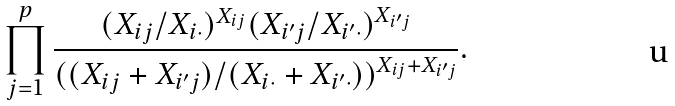Convert formula to latex. <formula><loc_0><loc_0><loc_500><loc_500>\prod _ { j = 1 } ^ { p } \frac { ( X _ { i j } / X _ { i \cdot } ) ^ { X _ { i j } } ( X _ { i ^ { \prime } j } / X _ { i ^ { \prime } \cdot } ) ^ { X _ { i ^ { \prime } j } } } { ( ( X _ { i j } + X _ { i ^ { \prime } j } ) / ( X _ { i \cdot } + X _ { i ^ { \prime } \cdot } ) ) ^ { X _ { i j } + X _ { i ^ { \prime } j } } } .</formula> 